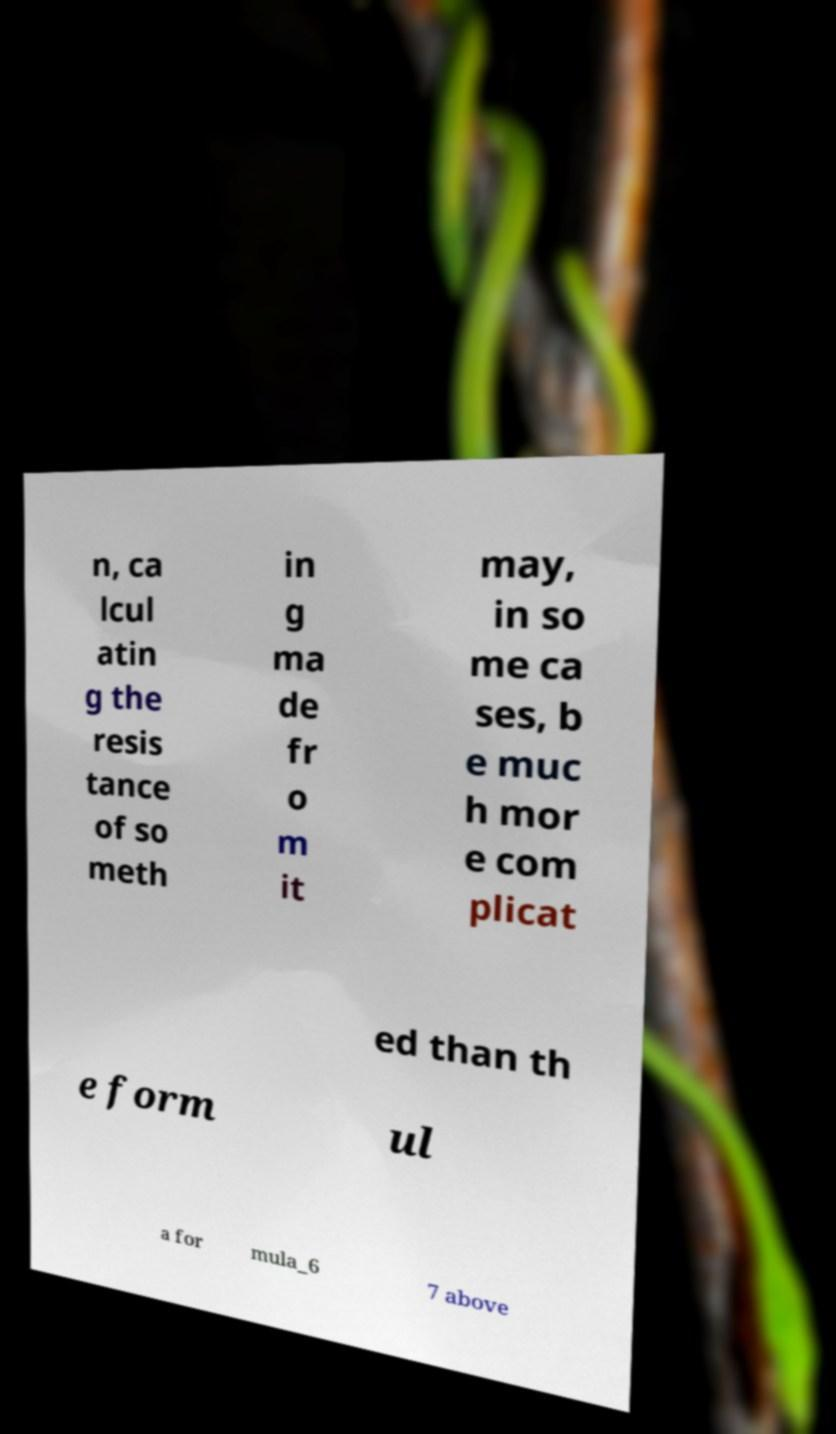Can you read and provide the text displayed in the image?This photo seems to have some interesting text. Can you extract and type it out for me? n, ca lcul atin g the resis tance of so meth in g ma de fr o m it may, in so me ca ses, b e muc h mor e com plicat ed than th e form ul a for mula_6 7 above 